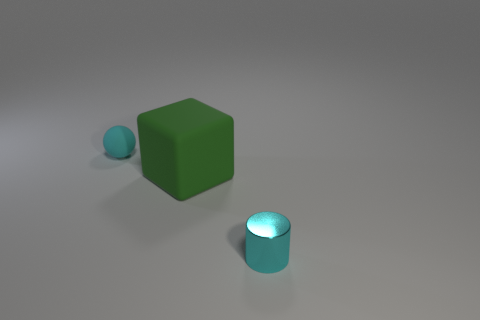Add 1 yellow shiny cylinders. How many objects exist? 4 Subtract all balls. How many objects are left? 2 Subtract all small spheres. Subtract all large green rubber objects. How many objects are left? 1 Add 3 cyan metallic things. How many cyan metallic things are left? 4 Add 2 small cyan things. How many small cyan things exist? 4 Subtract 1 green blocks. How many objects are left? 2 